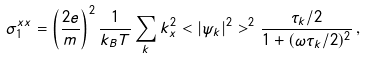<formula> <loc_0><loc_0><loc_500><loc_500>\sigma _ { 1 } ^ { x x } = \left ( \frac { 2 e } { m } \right ) ^ { 2 } \frac { 1 } { k _ { B } T } \sum _ { k } k _ { x } ^ { 2 } < | \psi _ { k } | ^ { 2 } > ^ { 2 } \frac { \tau _ { k } / 2 } { 1 + ( \omega \tau _ { k } / 2 ) ^ { 2 } } \, ,</formula> 